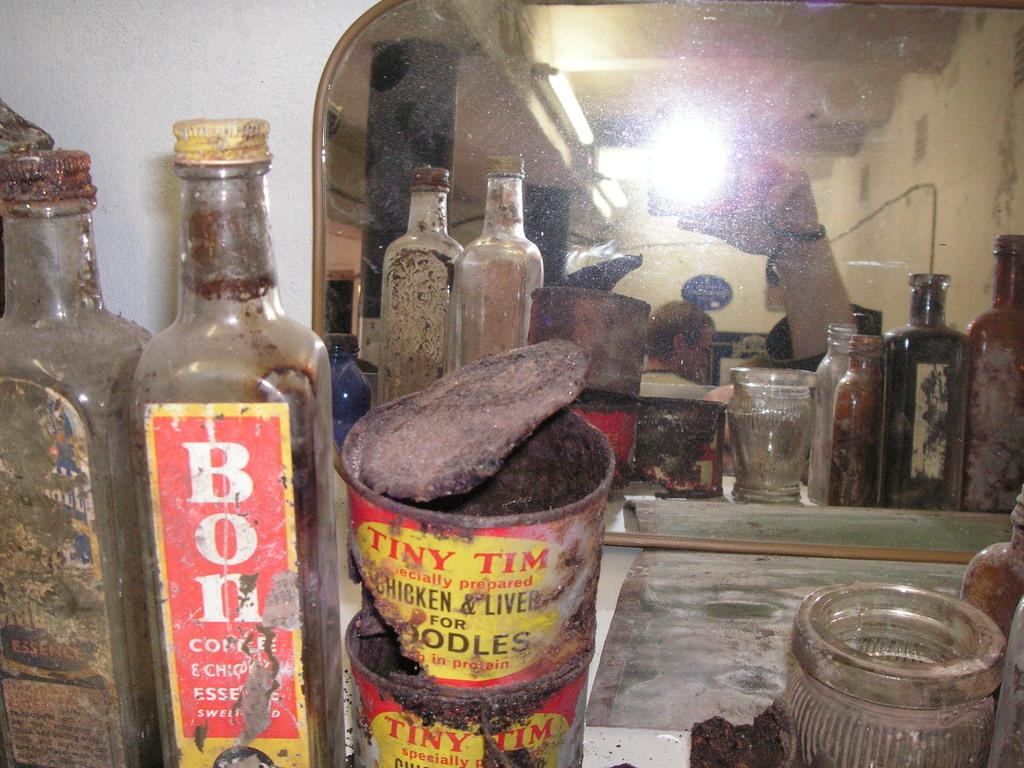<image>
Render a clear and concise summary of the photo. old dirty jars and bottles of Bon and Tiny Tim 